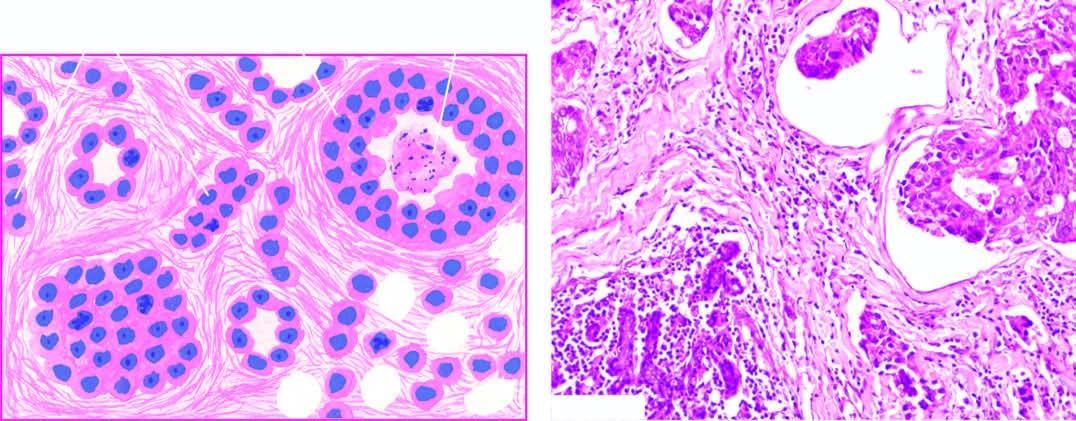do masses of large uniform tumour cells include formation of solid nests, cords, gland-like structures and intraductal growth pattern of anaplastic tumour cells?
Answer the question using a single word or phrase. No 